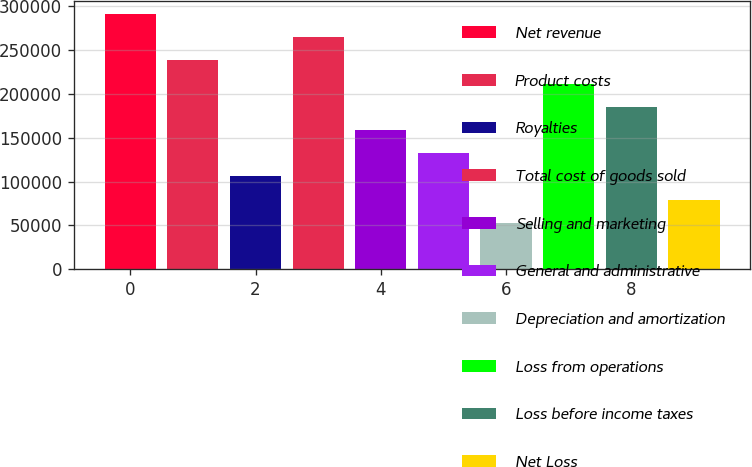Convert chart to OTSL. <chart><loc_0><loc_0><loc_500><loc_500><bar_chart><fcel>Net revenue<fcel>Product costs<fcel>Royalties<fcel>Total cost of goods sold<fcel>Selling and marketing<fcel>General and administrative<fcel>Depreciation and amortization<fcel>Loss from operations<fcel>Loss before income taxes<fcel>Net Loss<nl><fcel>291479<fcel>238483<fcel>105993<fcel>264981<fcel>158989<fcel>132491<fcel>52996.5<fcel>211985<fcel>185487<fcel>79494.6<nl></chart> 